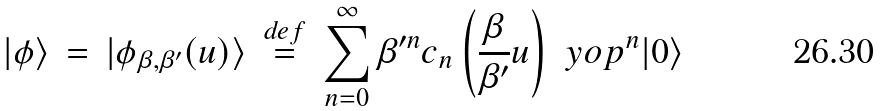Convert formula to latex. <formula><loc_0><loc_0><loc_500><loc_500>| \phi \rangle \, = \, | \phi _ { \beta , \beta ^ { \prime } } ( u ) \rangle \, \stackrel { d e f } { = } \, \sum _ { n = 0 } ^ { \infty } \beta ^ { \prime n } c _ { n } \left ( \frac { \beta } { \beta ^ { \prime } } u \right ) \ y o p ^ { n } | 0 \rangle</formula> 